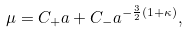Convert formula to latex. <formula><loc_0><loc_0><loc_500><loc_500>\mu = C _ { + } a + C _ { - } a ^ { - { \frac { 3 } { 2 } } ( 1 + \kappa ) } ,</formula> 